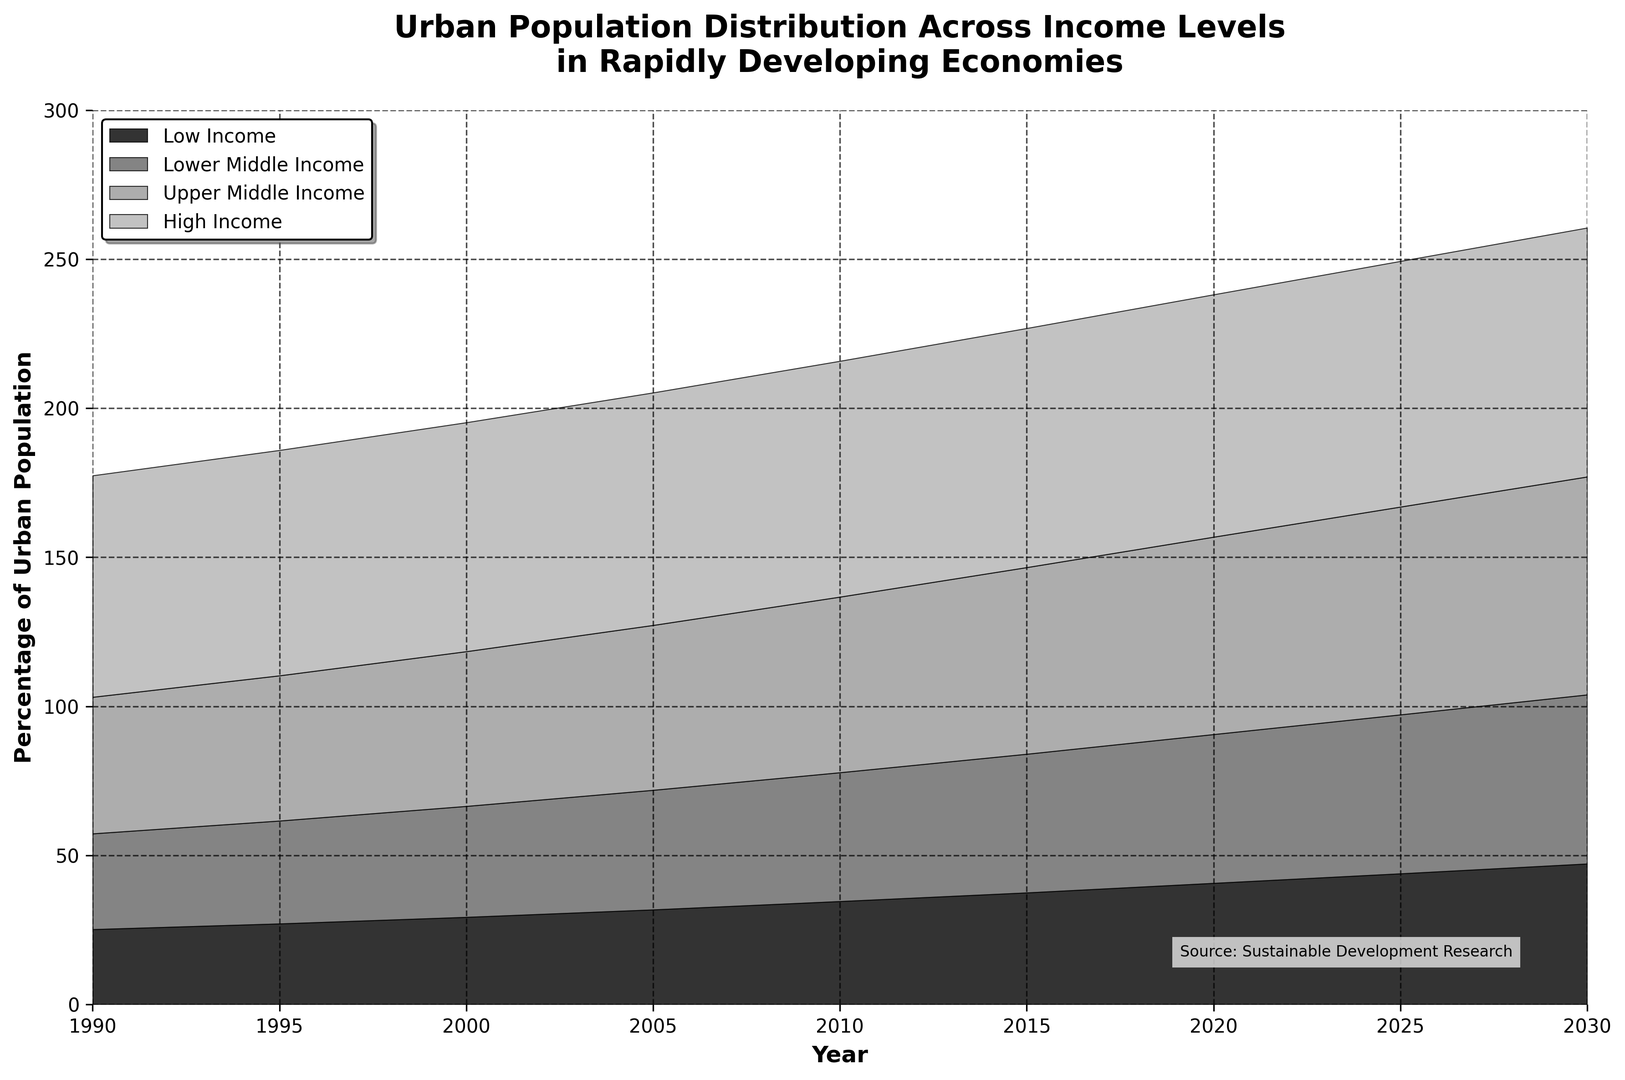What is the overall trend in urban population percentages for high-income countries from 1990 to 2030? The plot shows an increasing trend for high-income countries' urban population, starting from approximately 74.3% in 1990 and rising to around 83.5% by 2030.
Answer: Increasing Which income level group shows the most significant increase in urban population percentage from 1990 to 2030? Comparing all groups, the low-income group increases from 25.2% in 1990 to 47.2% in 2030, which is approximately a 22% increase. This is the largest change among the groups.
Answer: Low Income What is the difference in urban population percentages between high-income and low-income countries in 2020? In 2020, the high-income group is at 81.3%, while the low-income group is at 40.7%. The difference between them is 81.3% - 40.7% = 40.6%.
Answer: 40.6% Based on the visual pattern, how does the urban population growth rate seem to change over time for upper middle-income countries? The shading area for upper middle-income countries gets wider over the years, indicating a continuous increase. The growth rate accelerates as the curve steepens between 1990 and 2030.
Answer: Accelerates How do the growth patterns of low-income and lower-middle-income groups compare from 1990 to 2030? Both groups show an increasing trend, but the low-income group’s urban population grows more sharply, catching up with the lower-middle-income group by narrowing the gap over time.
Answer: Low-income grows more sharply Of the four income groups, which group has the highest urban population percentage in 2030? In the plot for 2030, the high-income group sits at the top with the highest urban population percentage of approximately 83.5%.
Answer: High Income How does the urban population distribution in lower-middle-income countries change from 1990 to 2010? The urban population percentage in lower-middle-income countries increases from 32.1% in 1990 to 43.2% in 2010.
Answer: Increases from 32.1% to 43.2% What year does the urban population percentage of low-income countries first exceed 30%? Based on the visual trend, the low-income country urban population percentage surpasses 30% between 2000 and 2005.
Answer: Between 2000 and 2005 In which year do high-income countries show the smallest increase in urban population percentage compared to the previous period? Comparing the increments, the smallest increase is observed between 2015 (80.2%) and 2020 (81.3%), with just a 1.1% rise.
Answer: 2015 to 2020 Considering the entire timeline from 1990 to 2030, which income group shows the steadiest growth in urban population percentage? The high-income group shows the steadiest and most consistent growth in urban population percentage over the entire period.
Answer: High Income 